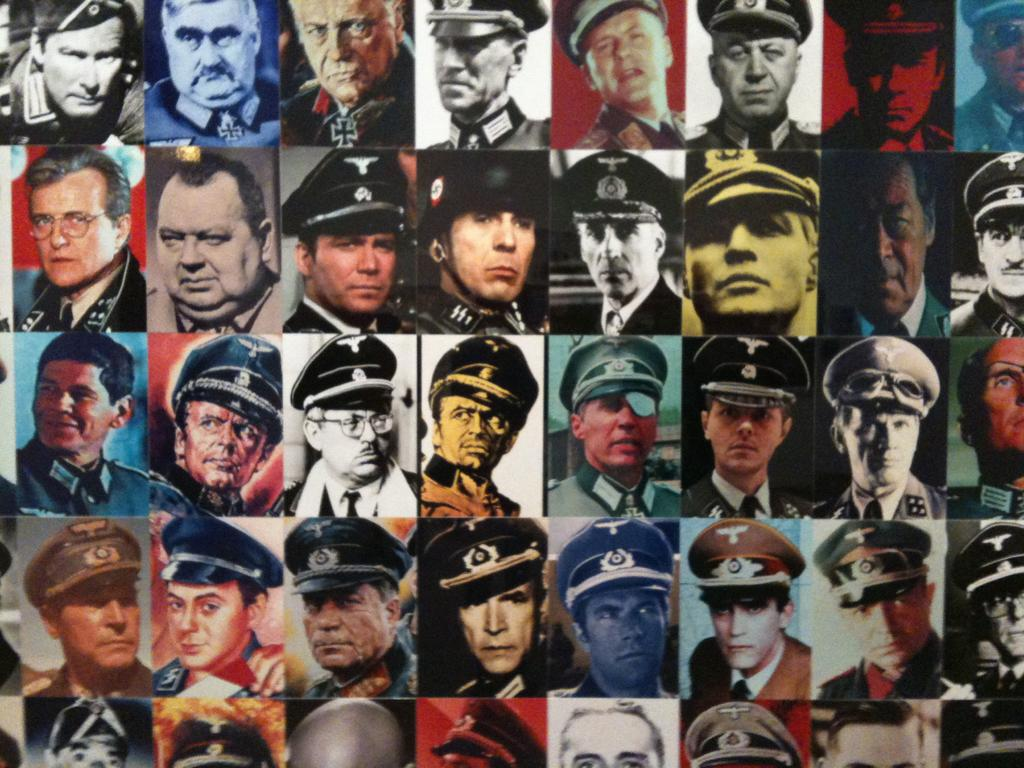What type of image is being described? The image is a collage. What can be found within the collage? The collage contains faces of persons. What type of behavior is exhibited by the faces in the collage? The faces in the collage do not exhibit any behavior, as they are static images. 